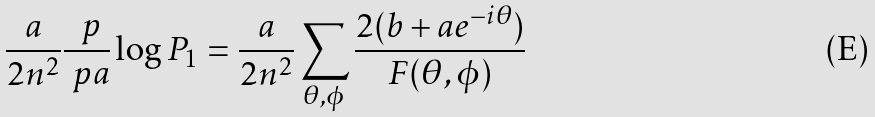Convert formula to latex. <formula><loc_0><loc_0><loc_500><loc_500>\frac { a } { 2 n ^ { 2 } } \frac { \ p } { \ p a } \log P _ { 1 } = \frac { a } { 2 n ^ { 2 } } \sum _ { \theta , \phi } \frac { 2 ( b + a e ^ { - i \theta } ) } { F ( \theta , \phi ) }</formula> 